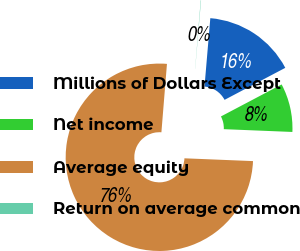Convert chart to OTSL. <chart><loc_0><loc_0><loc_500><loc_500><pie_chart><fcel>Millions of Dollars Except<fcel>Net income<fcel>Average equity<fcel>Return on average common<nl><fcel>15.93%<fcel>8.37%<fcel>75.64%<fcel>0.06%<nl></chart> 